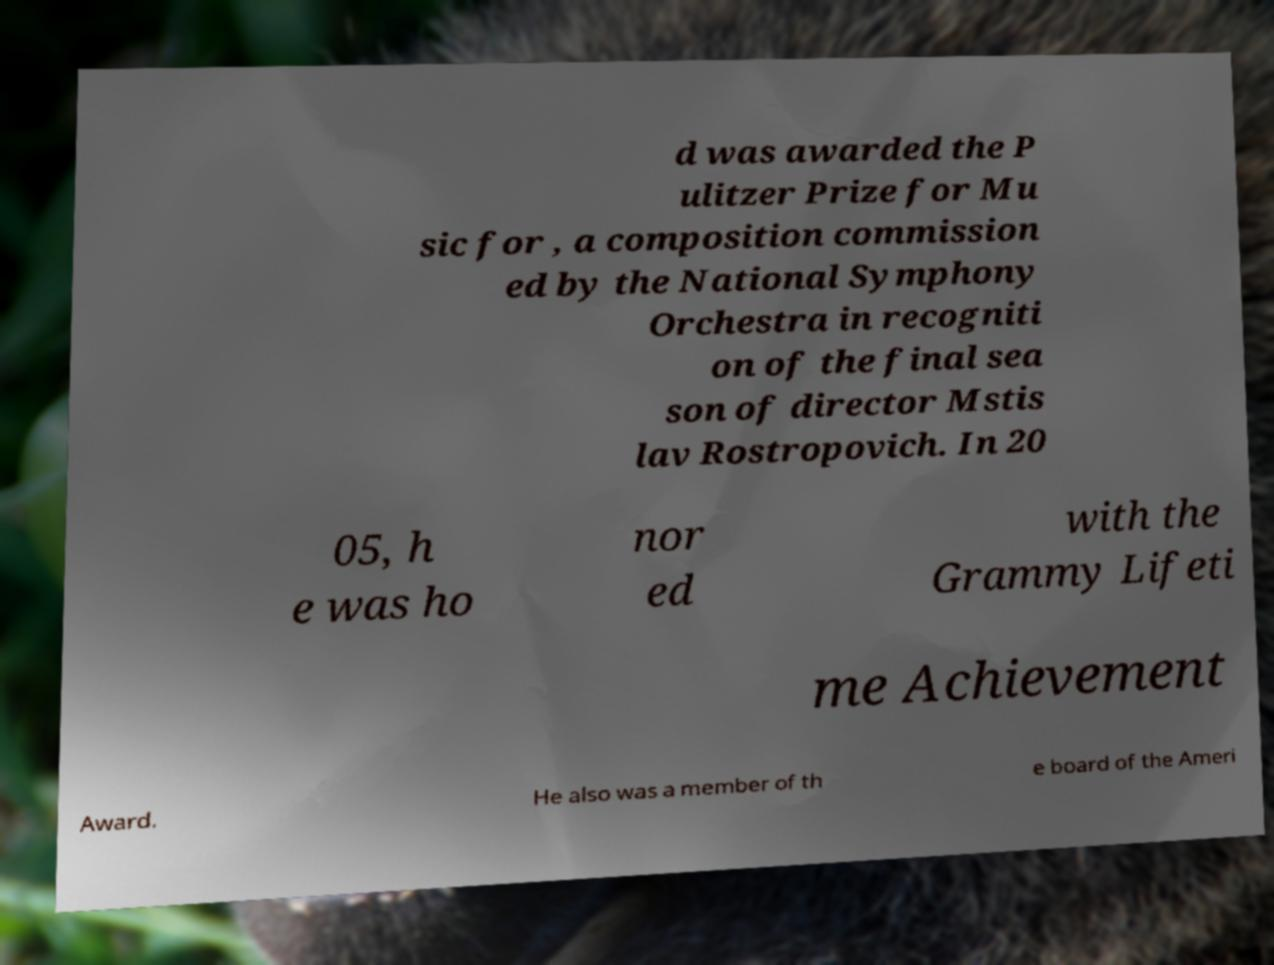Can you read and provide the text displayed in the image?This photo seems to have some interesting text. Can you extract and type it out for me? d was awarded the P ulitzer Prize for Mu sic for , a composition commission ed by the National Symphony Orchestra in recogniti on of the final sea son of director Mstis lav Rostropovich. In 20 05, h e was ho nor ed with the Grammy Lifeti me Achievement Award. He also was a member of th e board of the Ameri 